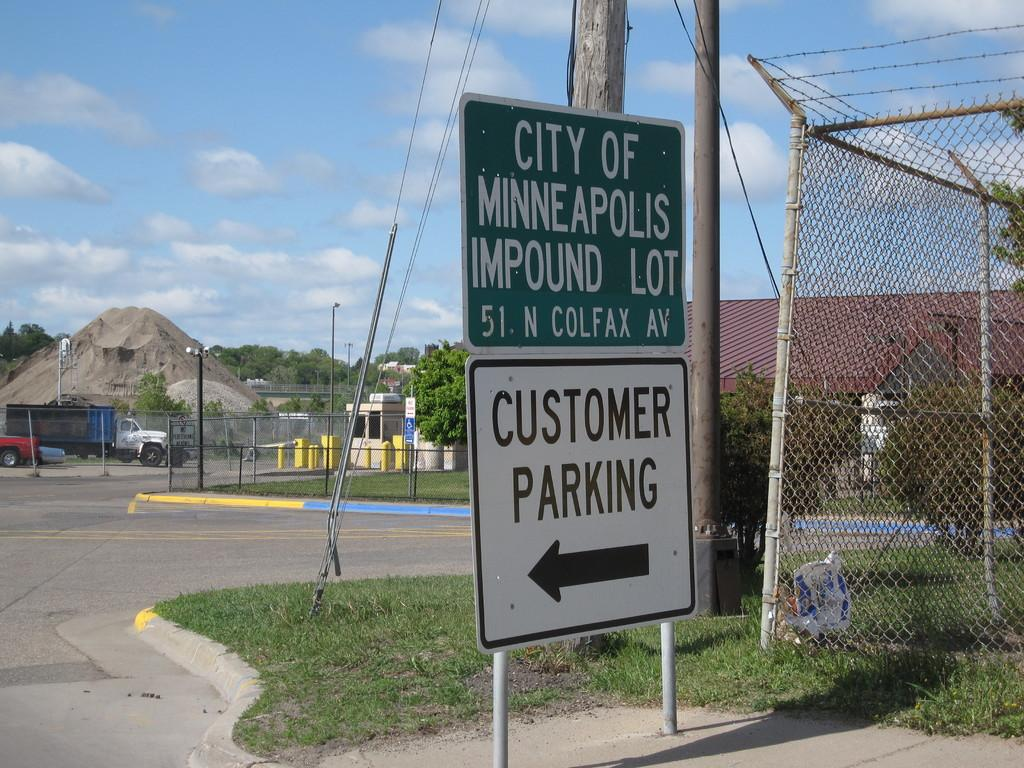<image>
Render a clear and concise summary of the photo. A green and white sign for the Minneapolis impound lot. 